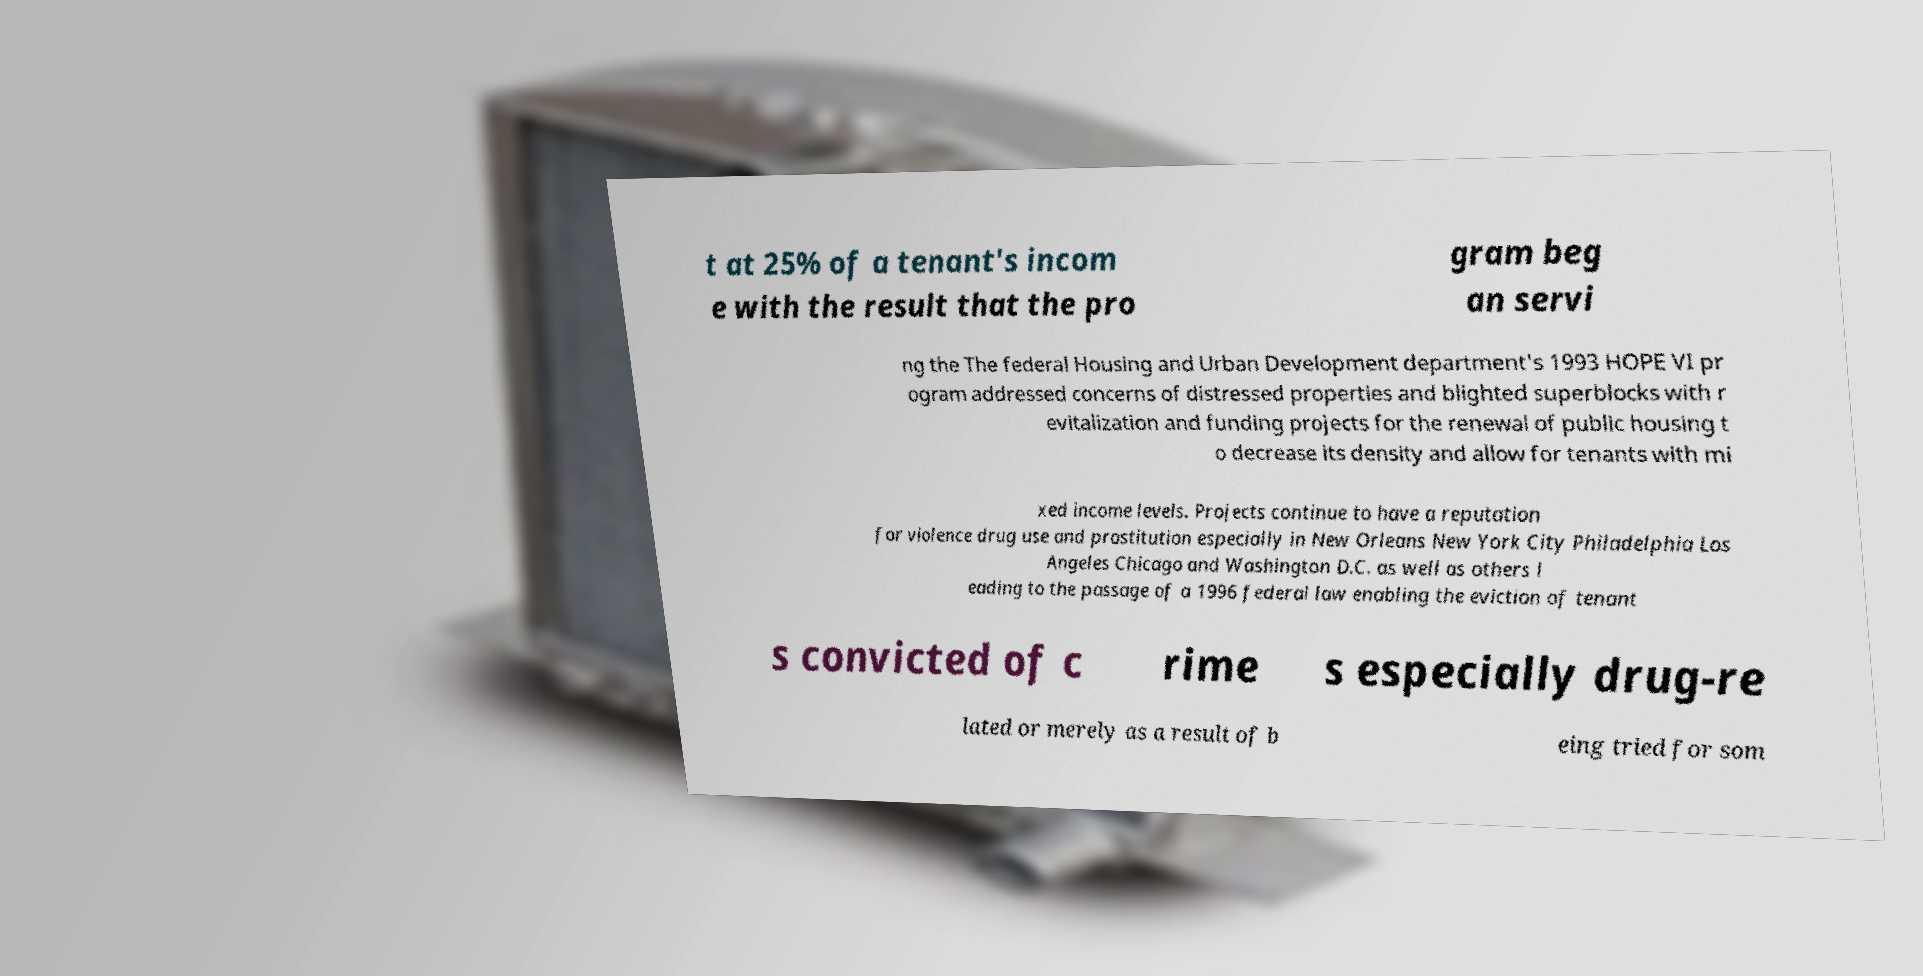For documentation purposes, I need the text within this image transcribed. Could you provide that? t at 25% of a tenant's incom e with the result that the pro gram beg an servi ng the The federal Housing and Urban Development department's 1993 HOPE VI pr ogram addressed concerns of distressed properties and blighted superblocks with r evitalization and funding projects for the renewal of public housing t o decrease its density and allow for tenants with mi xed income levels. Projects continue to have a reputation for violence drug use and prostitution especially in New Orleans New York City Philadelphia Los Angeles Chicago and Washington D.C. as well as others l eading to the passage of a 1996 federal law enabling the eviction of tenant s convicted of c rime s especially drug-re lated or merely as a result of b eing tried for som 